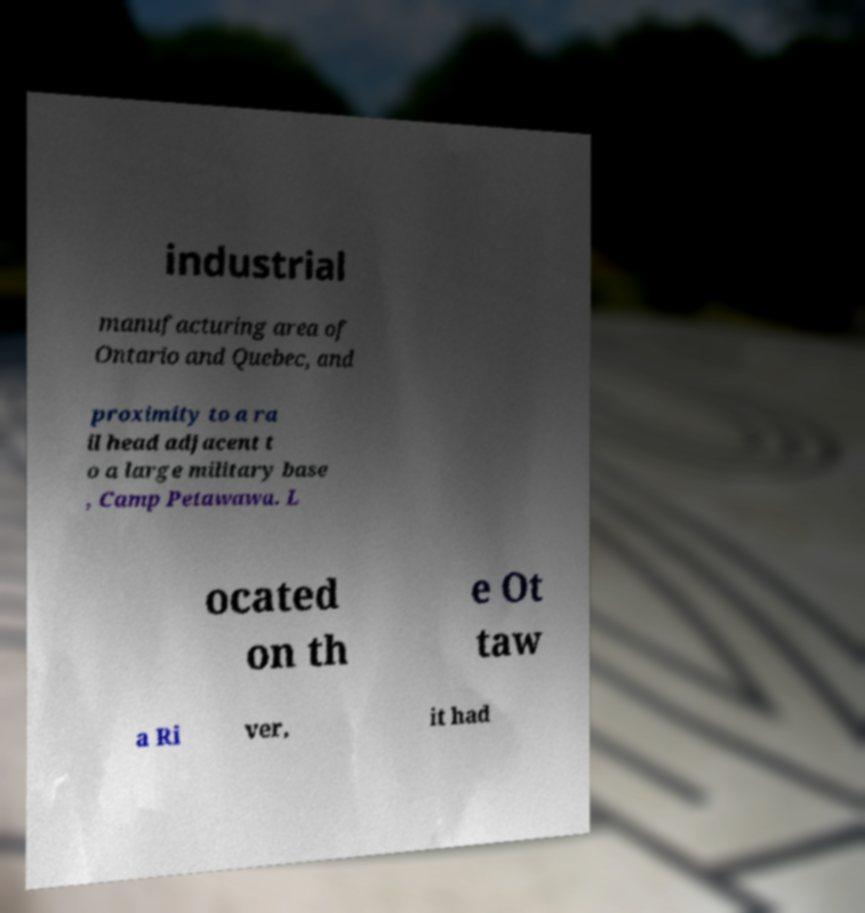Please read and relay the text visible in this image. What does it say? industrial manufacturing area of Ontario and Quebec, and proximity to a ra il head adjacent t o a large military base , Camp Petawawa. L ocated on th e Ot taw a Ri ver, it had 